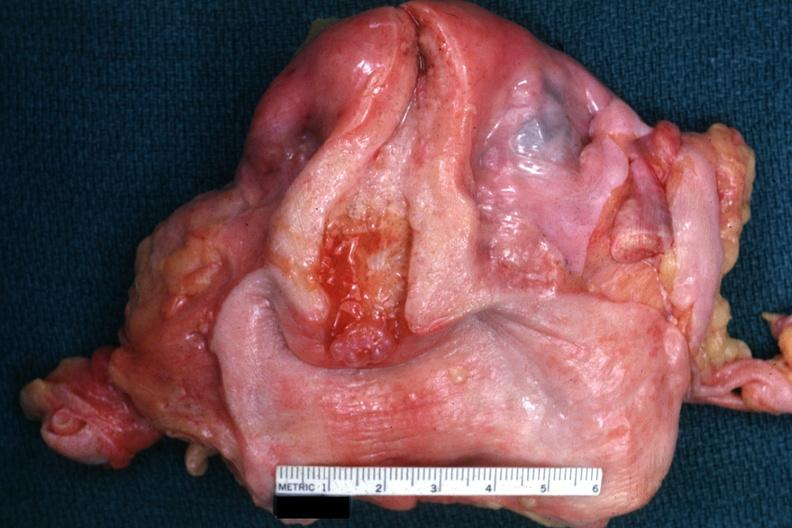how does this image show excellent example?
Answer the question using a single word or phrase. With opened uterus and cervix and vagina 